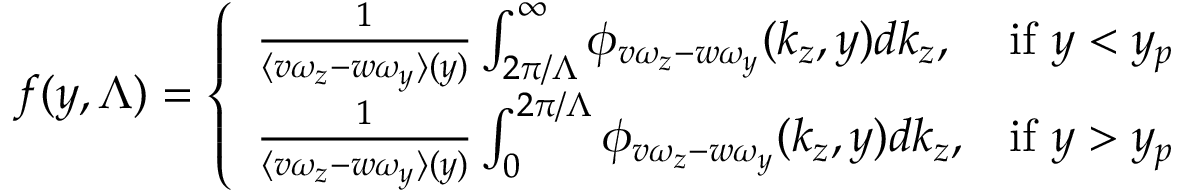Convert formula to latex. <formula><loc_0><loc_0><loc_500><loc_500>f ( y , \Lambda ) = \left \{ \begin{array} { l l } { \frac { 1 } { \langle v \omega _ { z } - w \omega _ { y } \rangle ( y ) } \int _ { 2 \pi / \Lambda } ^ { \infty } \phi _ { v \omega _ { z } - w \omega _ { y } } ( k _ { z } , y ) d k _ { z } , } & { i f y < y _ { p } } \\ { \frac { 1 } { \langle v \omega _ { z } - w \omega _ { y } \rangle ( y ) } \int _ { 0 } ^ { 2 \pi / \Lambda } \phi _ { v \omega _ { z } - w \omega _ { y } } ( k _ { z } , y ) d k _ { z } , } & { i f y > y _ { p } } \end{array}</formula> 